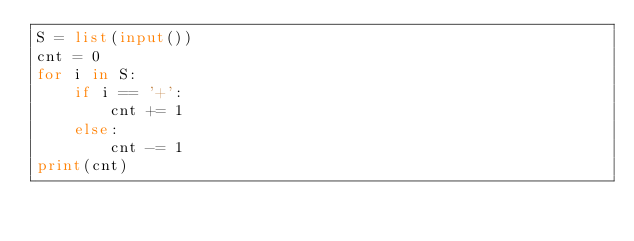<code> <loc_0><loc_0><loc_500><loc_500><_Python_>S = list(input())
cnt = 0
for i in S:
    if i == '+':
        cnt += 1
    else:
        cnt -= 1
print(cnt)</code> 